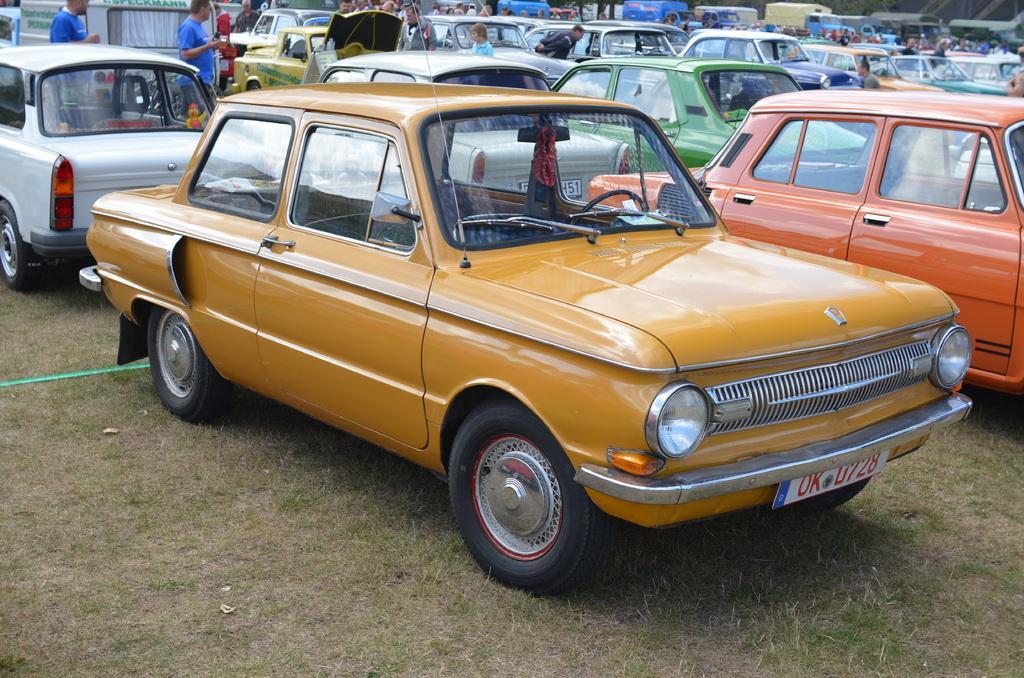Could you give a brief overview of what you see in this image? In this image we can see a group of cars placed on the ground. We can also see some grass and a group of people standing. On the backside we can see some vehicles. 